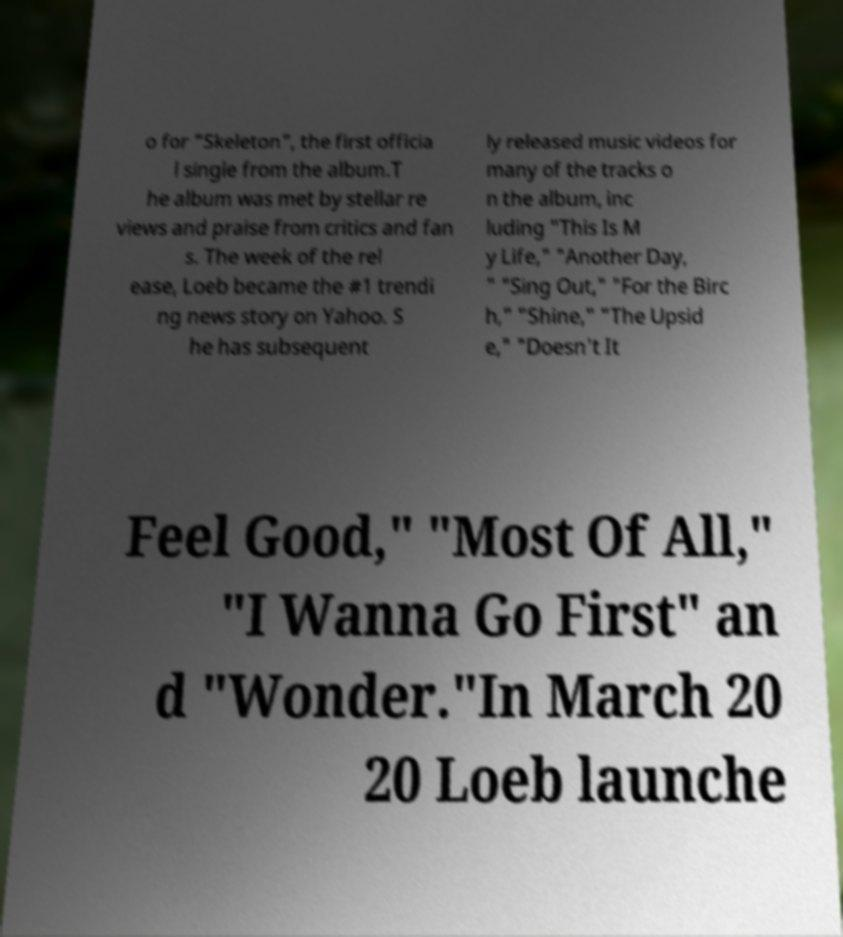Please identify and transcribe the text found in this image. o for "Skeleton", the first officia l single from the album.T he album was met by stellar re views and praise from critics and fan s. The week of the rel ease, Loeb became the #1 trendi ng news story on Yahoo. S he has subsequent ly released music videos for many of the tracks o n the album, inc luding "This Is M y Life," "Another Day, " "Sing Out," "For the Birc h," "Shine," "The Upsid e," "Doesn't It Feel Good," "Most Of All," "I Wanna Go First" an d "Wonder."In March 20 20 Loeb launche 